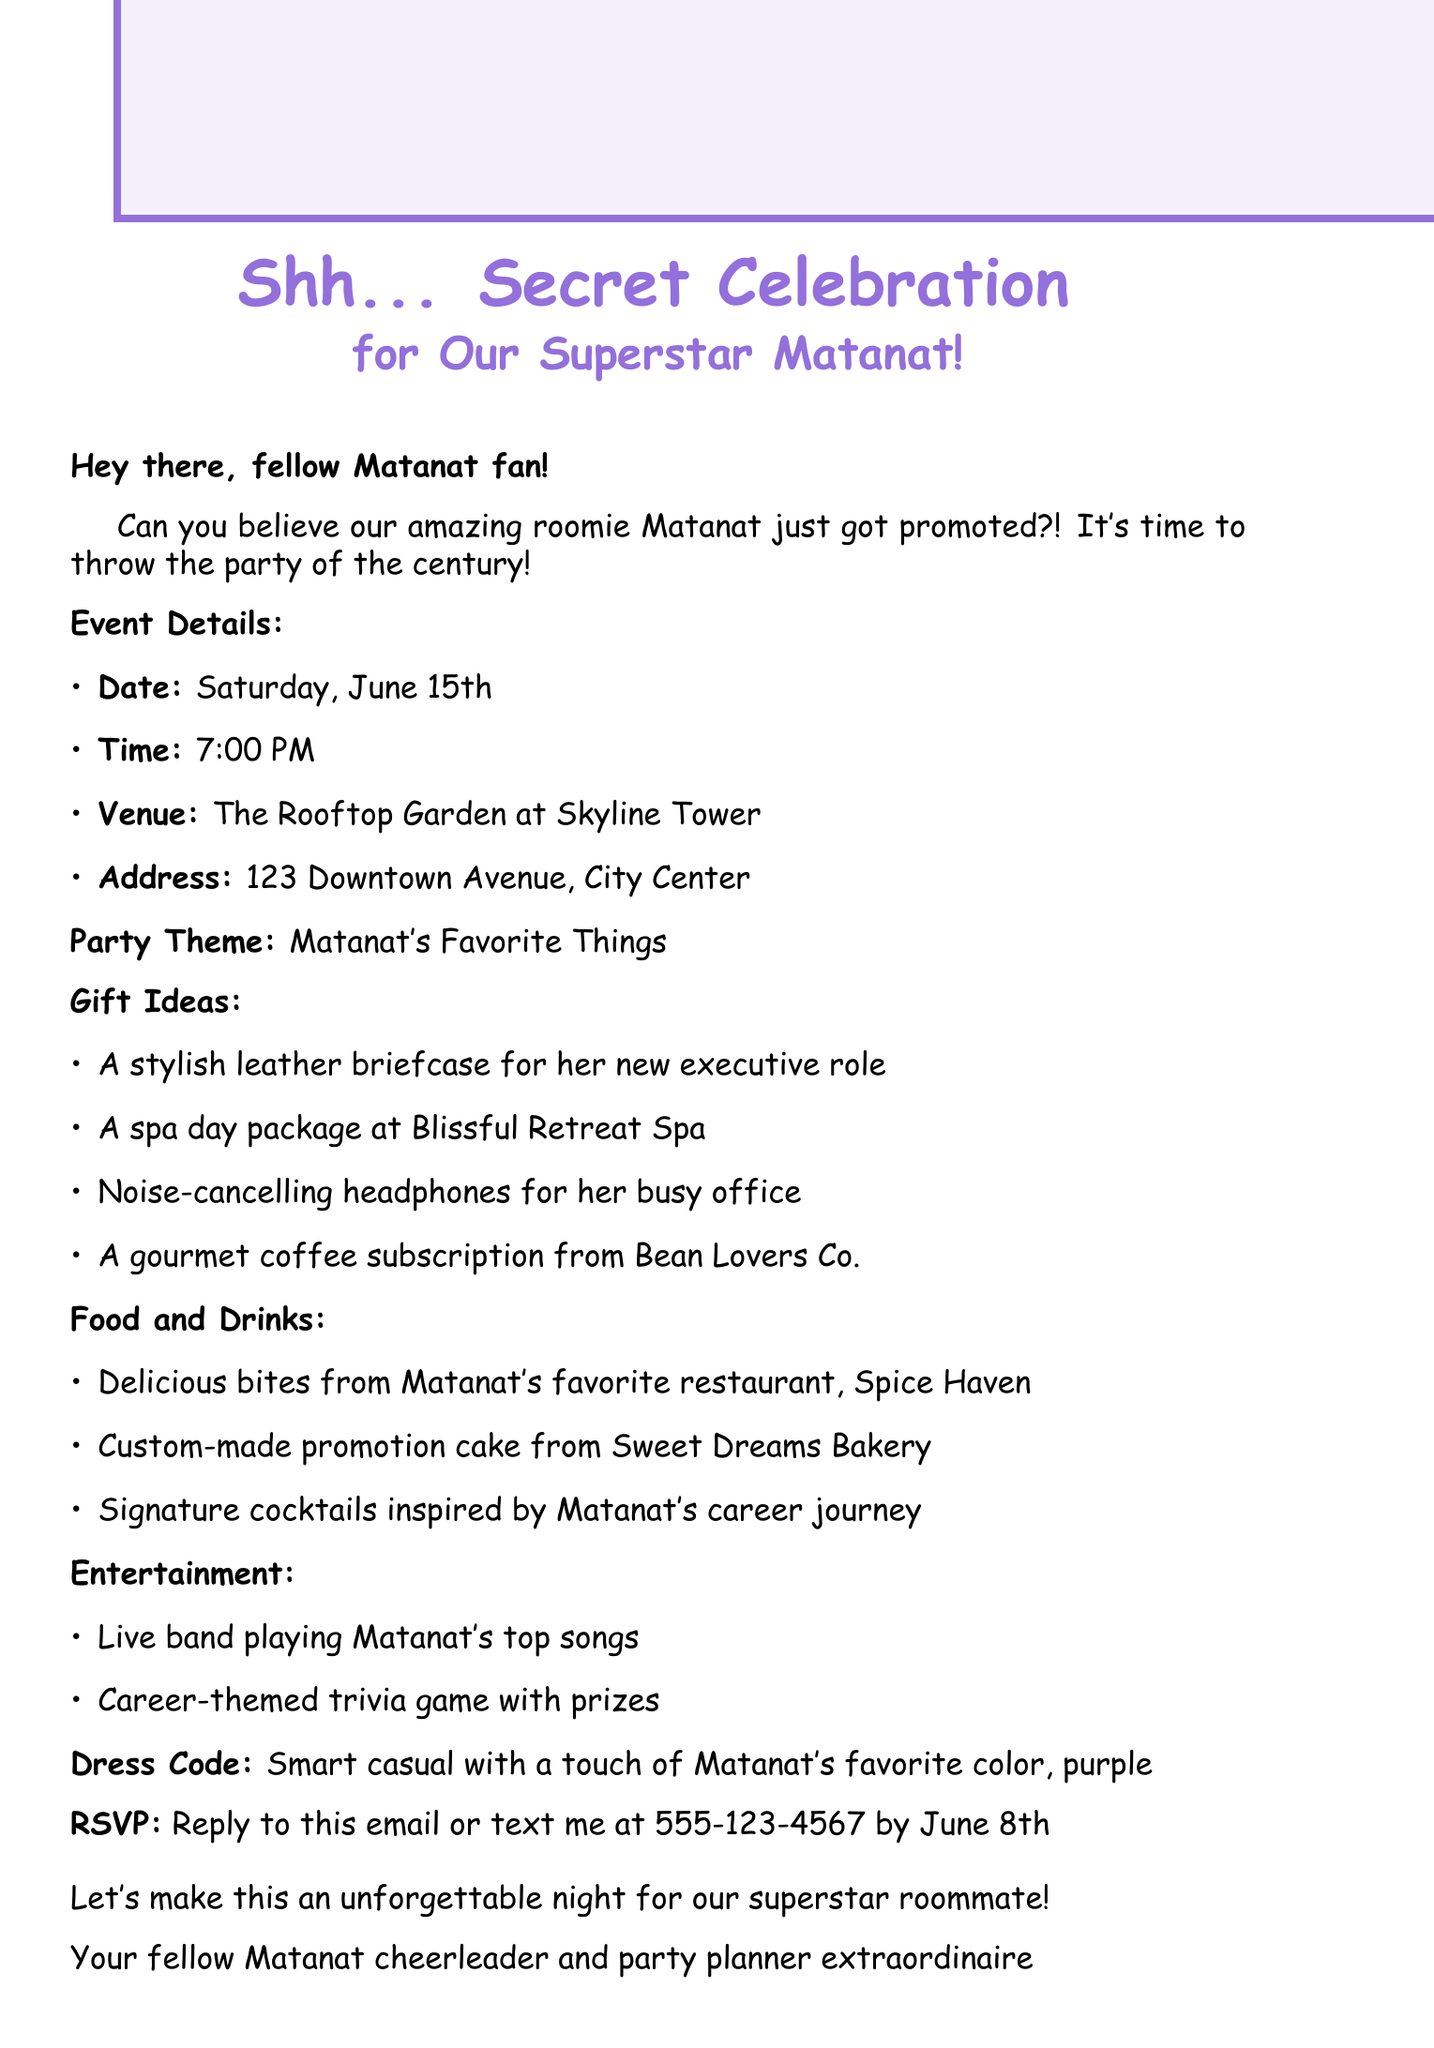What is the date of the surprise party? The date of the surprise party is stated in the event details in the document.
Answer: Saturday, June 15th What is the venue for the party? The venue is specified in the event details section of the document.
Answer: The Rooftop Garden at Skyline Tower What time does the party start? The starting time of the party is included in the event details in the document.
Answer: 7:00 PM What is one of the gift ideas for Matanat? The gift ideas are listed in a bullet point format in the document.
Answer: A stylish leather briefcase for her new executive role What should guests wear to the party? The dress code is provided in the party details section of the document.
Answer: Smart casual with a touch of Matanat's favorite color, purple What is the RSVP deadline? The RSVP deadline is mentioned clearly in the RSVP section of the document.
Answer: June 8th What type of catering will be provided? The type of catering is listed under the food and drinks section in the document.
Answer: Delicious bites from Matanat's favorite restaurant, Spice Haven What entertainment will be available at the party? The types of entertainment are described in the entertainment section of the document.
Answer: Live band playing Matanat's top songs What is the theme of the party? The party theme is stated explicitly in the document.
Answer: Matanat's Favorite Things 